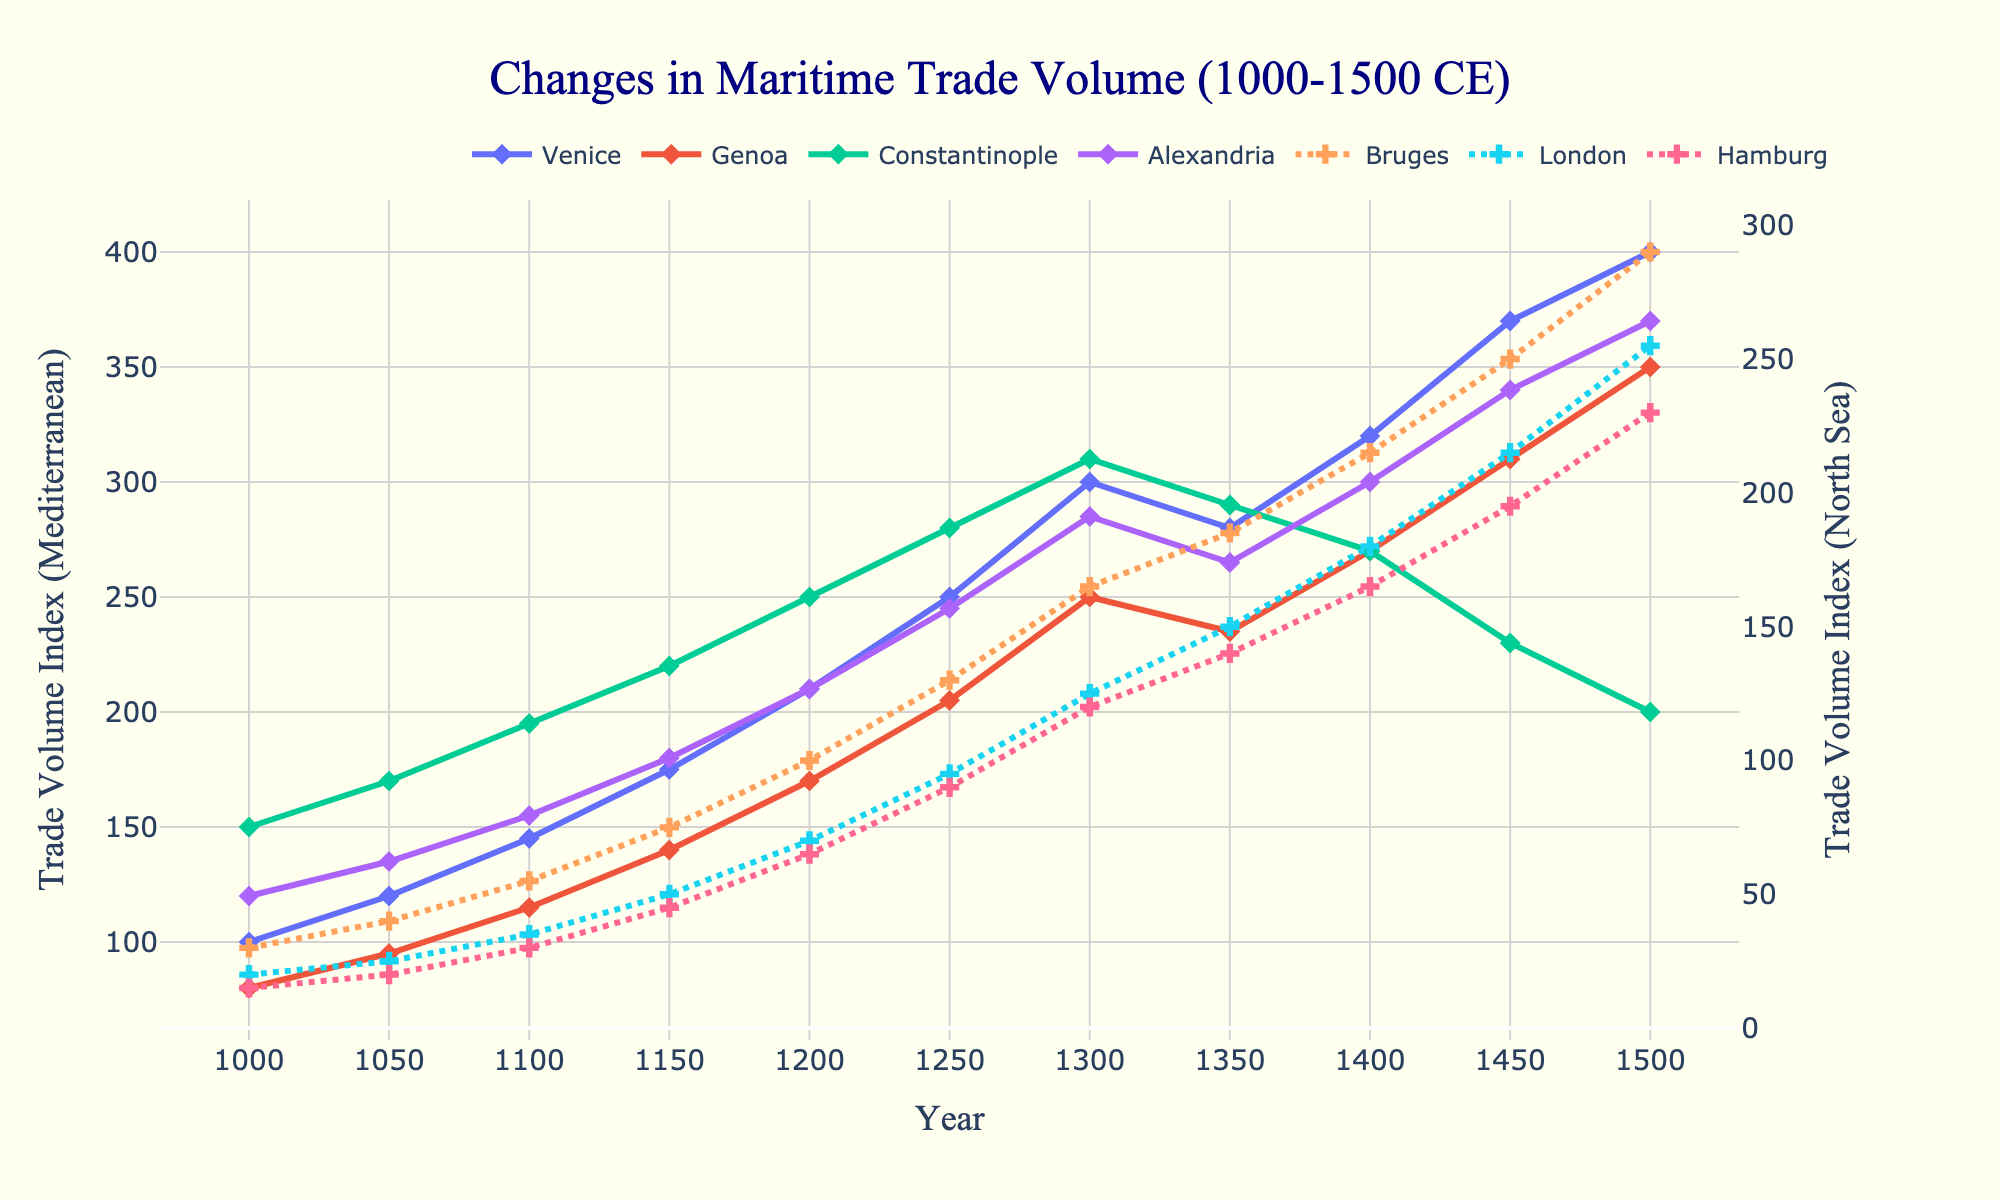What is the trade volume index for Venice in the year 1500? To find the trade volume index for Venice in 1500, look at the data points for Venice along the x-axis corresponding to the year 1500.
Answer: 400 Which city had a higher trade volume index in 1300, Constantinople or London? Compare the heights of the lines for Constantinople and London at the 1300 mark on the x-axis. Constantinople's line is higher than London’s line.
Answer: Constantinople Calculate the difference in trade volume index between Alexandria and Bruges in 1450. Find the trade volumes for Alexandria and Bruges in 1450 from the respective lines. Alexandria is 340, Bruges is 250. The difference is 340 - 250.
Answer: 90 Which Mediterranean city shows the most significant increase in trade volume index between 1000 and 1500? Compare the beginning and end points of all Mediterranean cities (Venice, Genoa, Constantinople, and Alexandria). Venice shows the highest increase from 100 to 400.
Answer: Venice What is the average trade volume index for Hamburg from 1000 to 1500? Add all the trade volume indices for Hamburg from 1000 to 1500 and divide by the number of data points (11). The sum is 15+20+30+45+65+90+120+140+165+195+230 = 1115. Dividing by 11 gives 1115/11.
Answer: 101.36 Which city had the least fluctuation in trade volume index over the given period? Analyze the lines for each city and observe which has the smallest changes in height. Hamburg’s line shows the least fluctuation overall.
Answer: Hamburg In which year did Genoa’s trade volume exceed 200 for the first time? Identify the year when Genoa's trade volume passes the 200 mark; it first exceeds 200 in the 1250 plot point.
Answer: 1250 By how much did the trade volume of London increase from 1100 to 1400? Find the trade volumes of London in 1100 and 1400, which are 35 and 180 respectively. Subtract the former from the latter: 180 - 35.
Answer: 145 Did any two cities have the same trade volume in any year? If so, which cities and in which year? Compare the lines across the chart to see if any cities share the same value at any year. In 1300, Hamburg and Bruges both have a trade volume of 120.
Answer: Bruges and Hamburg in 1300 